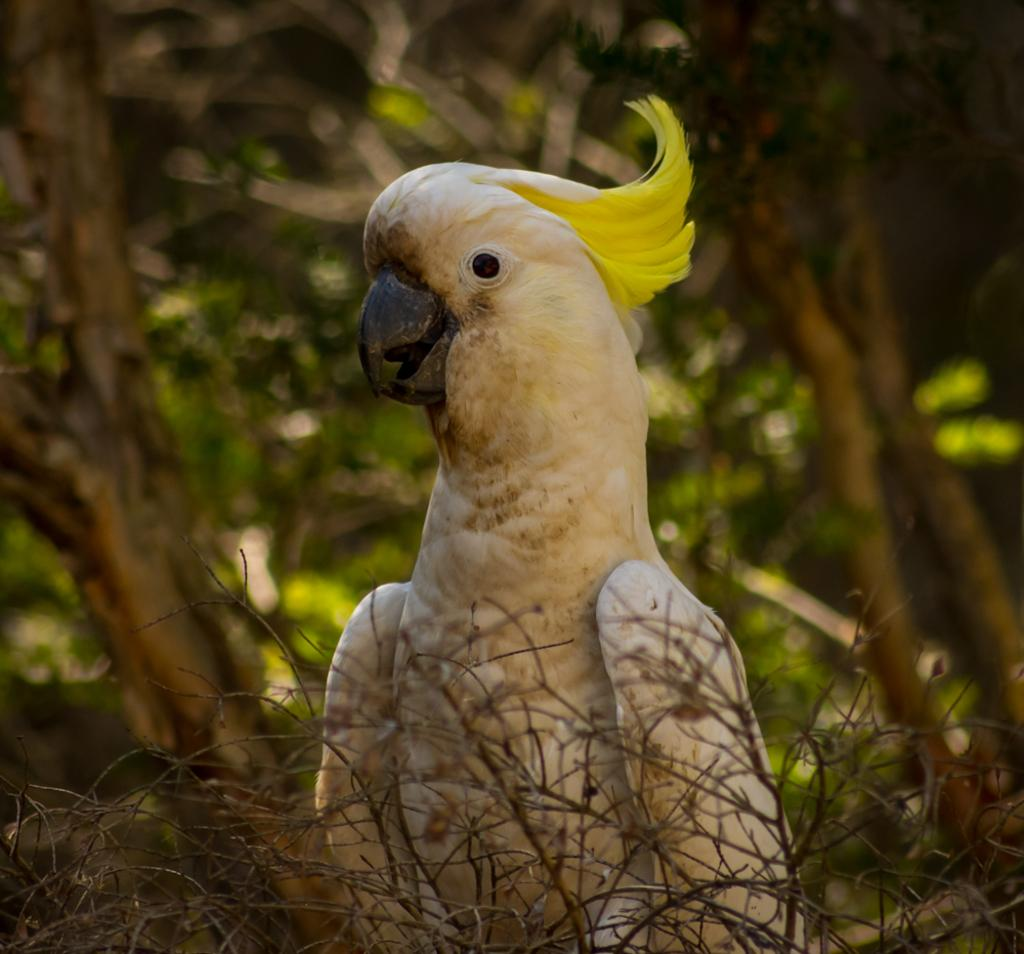What type of animal can be seen in the image? There is a bird in the image. What else is present in the image besides the bird? There are dried plants in the image. What can be seen in the background of the image? There are trees in the background of the image. What type of toe can be seen on the bird in the image? There are no visible toes on the bird in the image, as birds typically have claws instead of toes. 